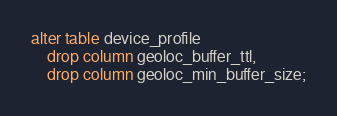Convert code to text. <code><loc_0><loc_0><loc_500><loc_500><_SQL_>alter table device_profile
    drop column geoloc_buffer_ttl,
    drop column geoloc_min_buffer_size;</code> 